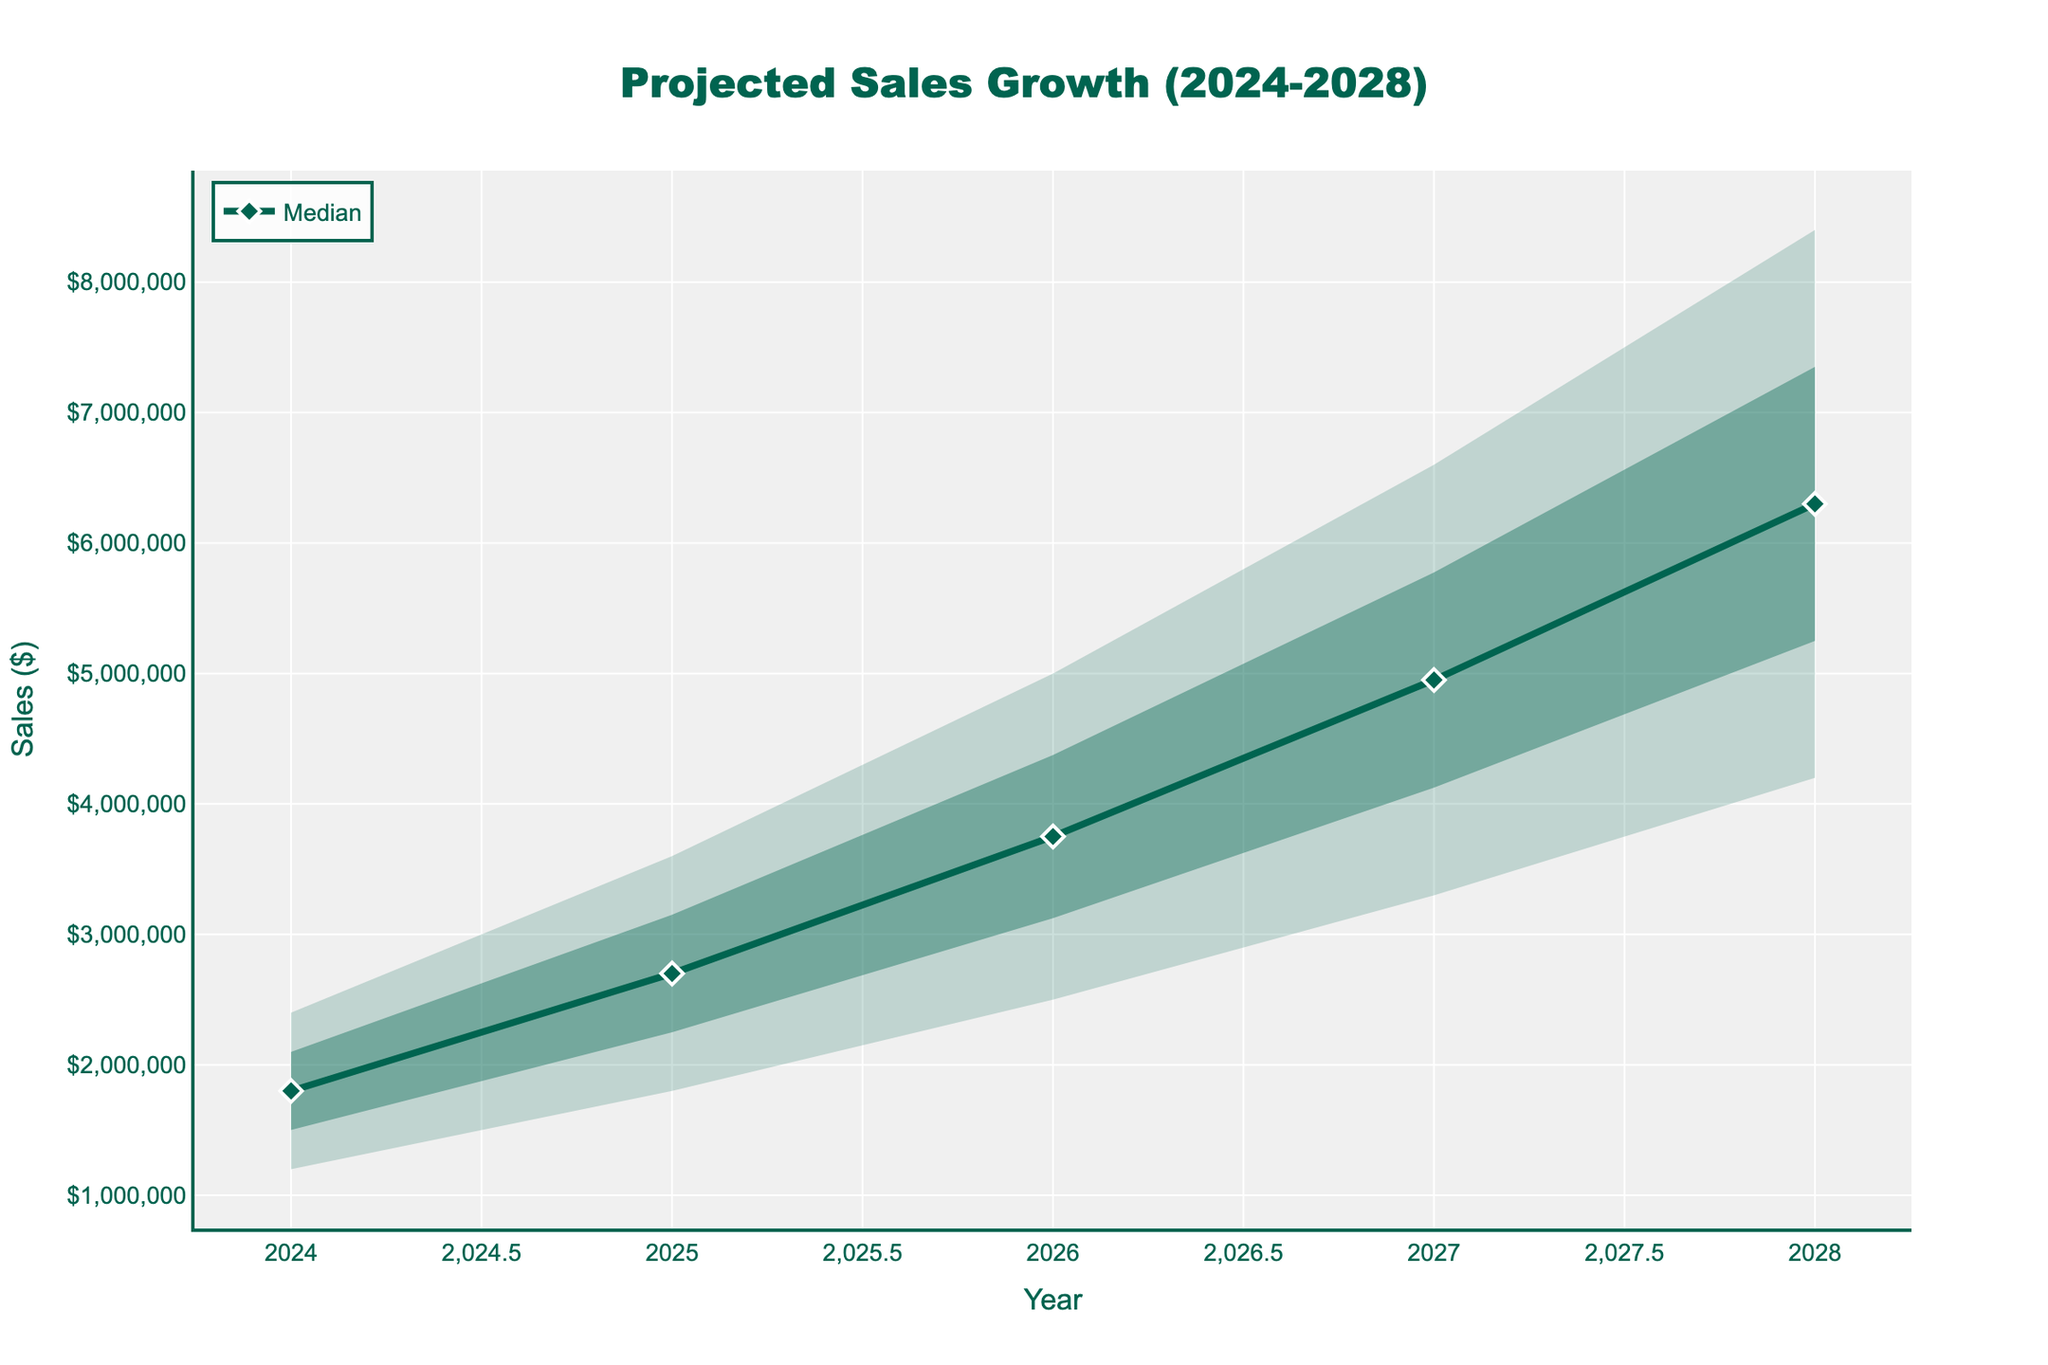What is the title of the fan chart? The title is displayed at the top center of the plot. It contains the main information about the chart's content.
Answer: Projected Sales Growth (2024-2028) What does the y-axis represent? The information is shown as the y-axis label on the left side of the chart.
Answer: Sales ($) In which year is the median sales value projected to be 4,950,000? The median line is depicted with markers in the chart. Find the year corresponding to the median value of 4,950,000.
Answer: 2027 What is the upper 80% confidence interval for the year 2025? Find the upper 80% CI line in the visualization. Then, locate the value for the year 2025.
Answer: 3,150,000 How does the median value change from 2024 to 2028? Examine the trend of the median line from 2024 to 2028 to observe the changes in sales values.
Answer: Increases from 1,800,000 to 6,300,000 What is the difference between the upper and lower 95% confidence interval in 2026? Calculate the difference between the upper 95% CI and the lower 95% CI for the year 2026.
Answer: 2,500,000 Which year shows the highest projected sales growth at the upper 95% confidence interval? Look at the uppermost limit of the confidence intervals. Identify the year with the highest value in the upper 95% CI.
Answer: 2028 Compare the range of the 80% confidence interval from 2024 to 2028. To compare the ranges, subtract the lower 80% CI from the upper 80% CI for both years and then compare the differences.
Answer: 2024: 600,000; 2028: 2,100,000 Which year shows the smallest gap between the median and the lower 95% confidence interval? Compare all years' median values with their lower 95% CI values and find out the year with the smallest gap.
Answer: 2024 What is the projected median sales growth in 2027 and how does it compare to 2025? Find the projected median values for 2027 and 2025, then calculate the difference.
Answer: 4,950,000; it is 2,250,000 more than 2025 